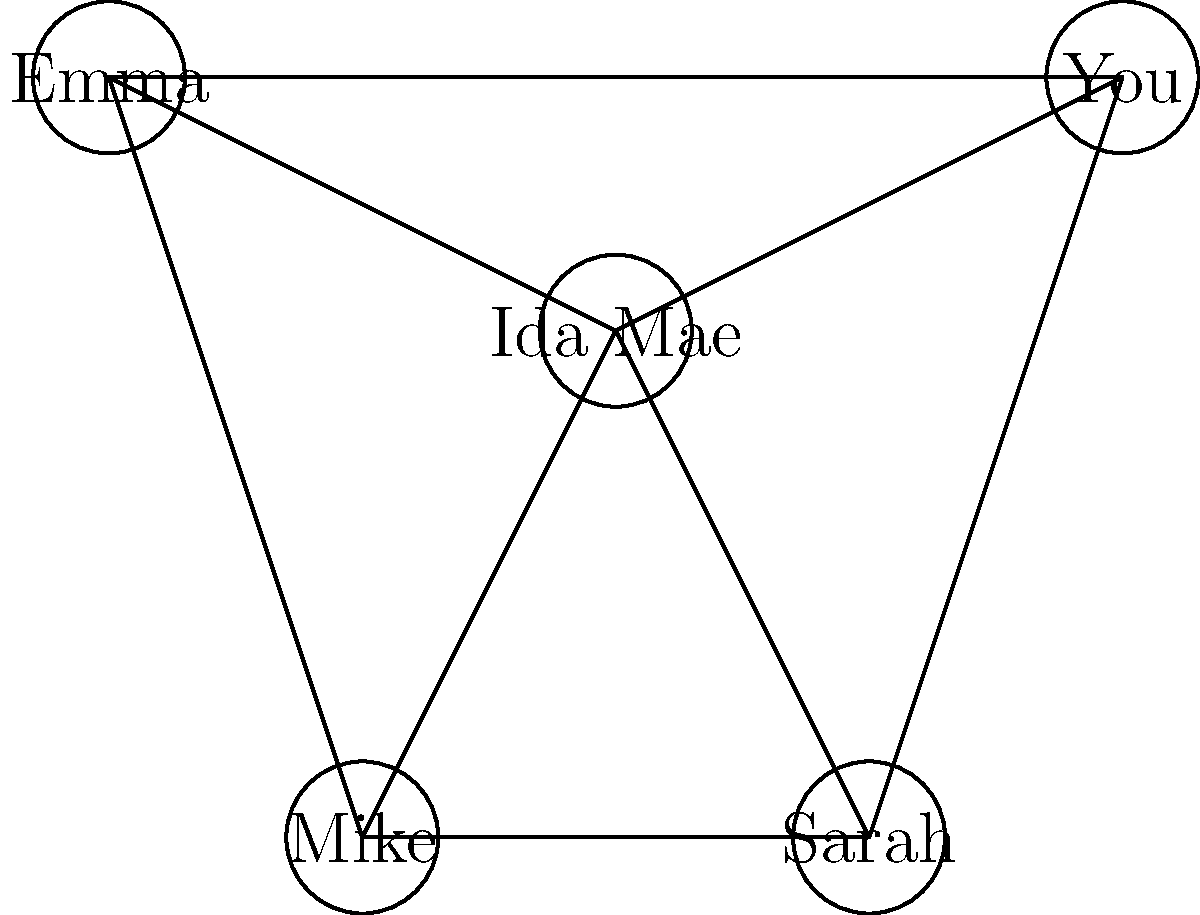Based on the social network graph shown, how many mutual friends do you and Ida Mae have in common? To determine the number of mutual friends between you and Ida Mae, we need to follow these steps:

1. Identify the nodes representing you and Ida Mae in the graph:
   - Ida Mae is represented by the central node
   - You are represented by the node labeled "You"

2. Identify the friends of Ida Mae:
   - Ida Mae is connected to all other nodes (You, Sarah, Mike, and Emma)

3. Identify your friends:
   - You are connected to Ida Mae, Sarah, and Emma

4. Find the intersection of these friend groups:
   - Sarah and Emma are connected to both you and Ida Mae

5. Count the number of mutual friends:
   - There are 2 mutual friends (Sarah and Emma)

Therefore, you and Ida Mae have 2 mutual friends in common according to this social network graph.
Answer: 2 